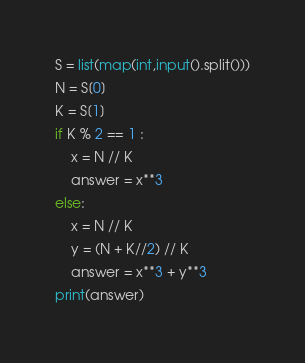<code> <loc_0><loc_0><loc_500><loc_500><_Python_>S = list(map(int,input().split()))
N = S[0]
K = S[1]
if K % 2 == 1 :
    x = N // K
    answer = x**3
else:
    x = N // K
    y = (N + K//2) // K
    answer = x**3 + y**3
print(answer)</code> 